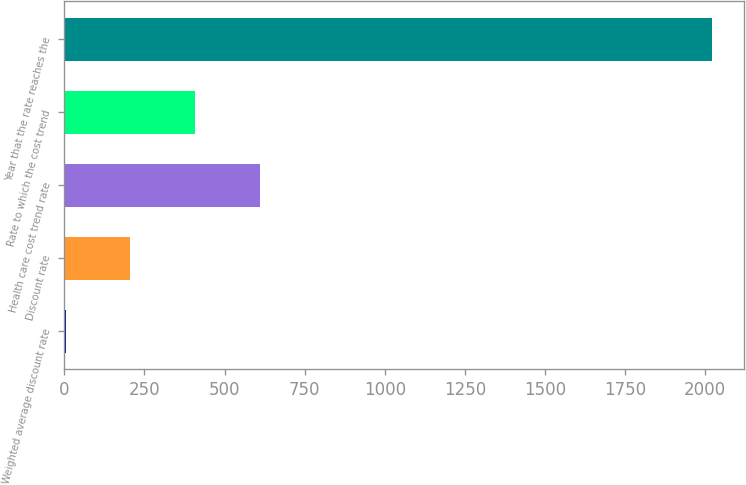Convert chart. <chart><loc_0><loc_0><loc_500><loc_500><bar_chart><fcel>Weighted average discount rate<fcel>Discount rate<fcel>Health care cost trend rate<fcel>Rate to which the cost trend<fcel>Year that the rate reaches the<nl><fcel>4.19<fcel>205.77<fcel>608.93<fcel>407.35<fcel>2020<nl></chart> 